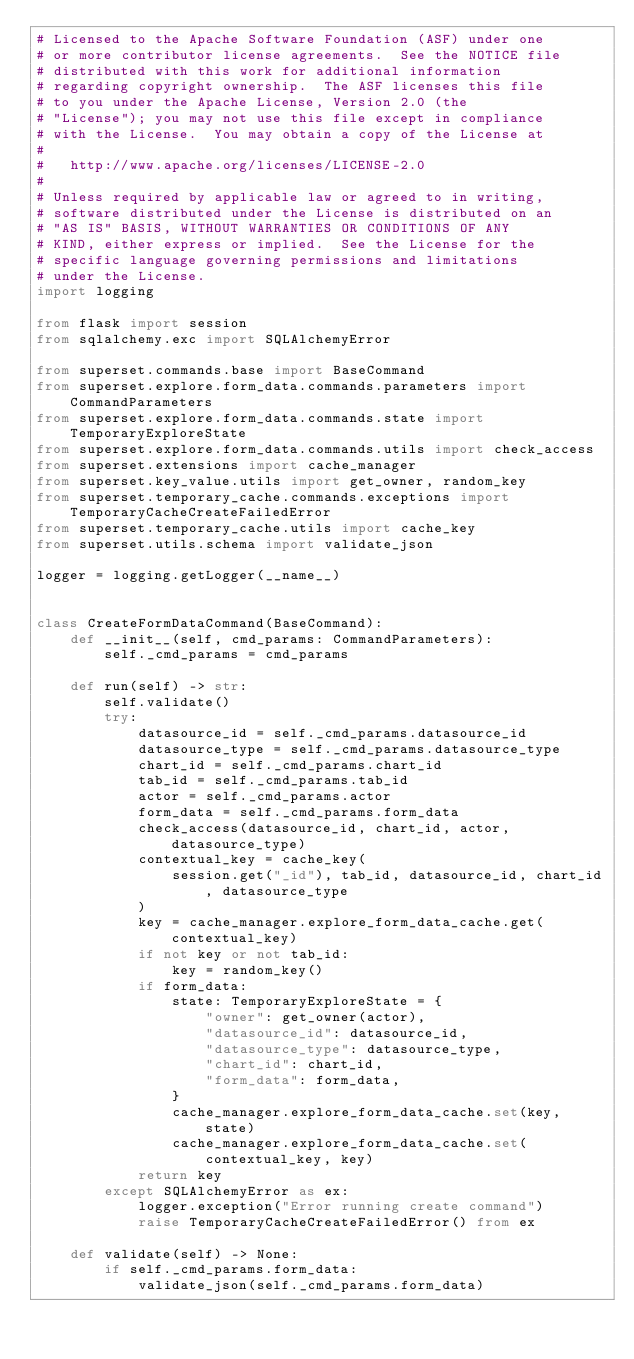Convert code to text. <code><loc_0><loc_0><loc_500><loc_500><_Python_># Licensed to the Apache Software Foundation (ASF) under one
# or more contributor license agreements.  See the NOTICE file
# distributed with this work for additional information
# regarding copyright ownership.  The ASF licenses this file
# to you under the Apache License, Version 2.0 (the
# "License"); you may not use this file except in compliance
# with the License.  You may obtain a copy of the License at
#
#   http://www.apache.org/licenses/LICENSE-2.0
#
# Unless required by applicable law or agreed to in writing,
# software distributed under the License is distributed on an
# "AS IS" BASIS, WITHOUT WARRANTIES OR CONDITIONS OF ANY
# KIND, either express or implied.  See the License for the
# specific language governing permissions and limitations
# under the License.
import logging

from flask import session
from sqlalchemy.exc import SQLAlchemyError

from superset.commands.base import BaseCommand
from superset.explore.form_data.commands.parameters import CommandParameters
from superset.explore.form_data.commands.state import TemporaryExploreState
from superset.explore.form_data.commands.utils import check_access
from superset.extensions import cache_manager
from superset.key_value.utils import get_owner, random_key
from superset.temporary_cache.commands.exceptions import TemporaryCacheCreateFailedError
from superset.temporary_cache.utils import cache_key
from superset.utils.schema import validate_json

logger = logging.getLogger(__name__)


class CreateFormDataCommand(BaseCommand):
    def __init__(self, cmd_params: CommandParameters):
        self._cmd_params = cmd_params

    def run(self) -> str:
        self.validate()
        try:
            datasource_id = self._cmd_params.datasource_id
            datasource_type = self._cmd_params.datasource_type
            chart_id = self._cmd_params.chart_id
            tab_id = self._cmd_params.tab_id
            actor = self._cmd_params.actor
            form_data = self._cmd_params.form_data
            check_access(datasource_id, chart_id, actor, datasource_type)
            contextual_key = cache_key(
                session.get("_id"), tab_id, datasource_id, chart_id, datasource_type
            )
            key = cache_manager.explore_form_data_cache.get(contextual_key)
            if not key or not tab_id:
                key = random_key()
            if form_data:
                state: TemporaryExploreState = {
                    "owner": get_owner(actor),
                    "datasource_id": datasource_id,
                    "datasource_type": datasource_type,
                    "chart_id": chart_id,
                    "form_data": form_data,
                }
                cache_manager.explore_form_data_cache.set(key, state)
                cache_manager.explore_form_data_cache.set(contextual_key, key)
            return key
        except SQLAlchemyError as ex:
            logger.exception("Error running create command")
            raise TemporaryCacheCreateFailedError() from ex

    def validate(self) -> None:
        if self._cmd_params.form_data:
            validate_json(self._cmd_params.form_data)
</code> 